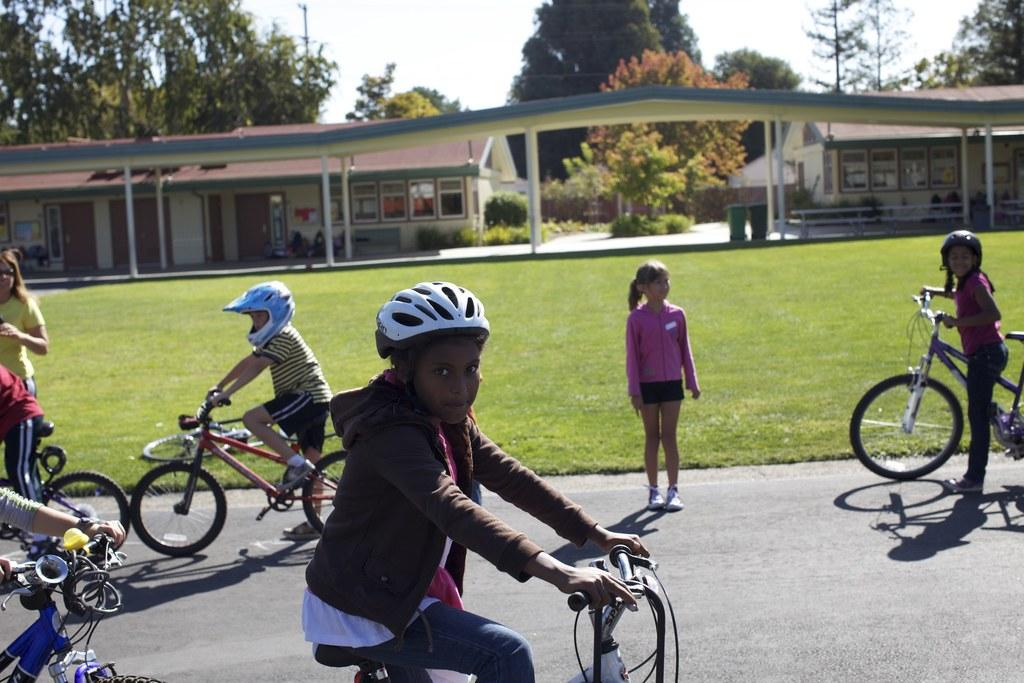What is the main feature of the image? There is a road in the image. What can be seen on the road? There are children on the road. What are some of the children doing on the road? Some children are riding bicycles, while others are standing. What type of vegetation is visible in the image? There is grass visible in the image. What else can be seen in the image besides the road and children? There are trees and buildings in the image. What color is the sweater worn by the ear on the thread in the image? There is no sweater, ear, or thread present in the image. 